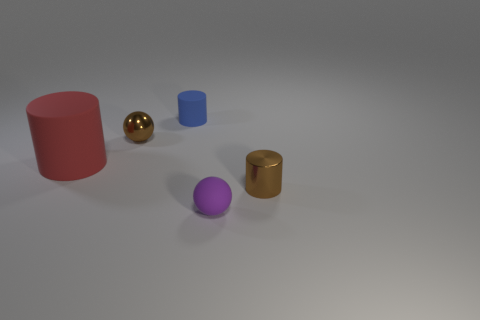The shiny sphere is what size?
Give a very brief answer. Small. There is a sphere on the left side of the blue matte cylinder; is its color the same as the shiny object right of the small purple sphere?
Your answer should be compact. Yes. How many other things are there of the same material as the tiny brown cylinder?
Make the answer very short. 1. Are there any large yellow cylinders?
Provide a succinct answer. No. Do the small ball that is in front of the red rubber thing and the large red thing have the same material?
Your response must be concise. Yes. There is a large red object that is the same shape as the tiny blue thing; what is it made of?
Your response must be concise. Rubber. There is a object that is the same color as the metal ball; what material is it?
Offer a terse response. Metal. Is the number of small blue things less than the number of rubber things?
Your answer should be compact. Yes. Is the color of the tiny metallic thing left of the tiny blue matte thing the same as the metal cylinder?
Provide a succinct answer. Yes. What is the color of the cylinder that is made of the same material as the brown ball?
Make the answer very short. Brown. 